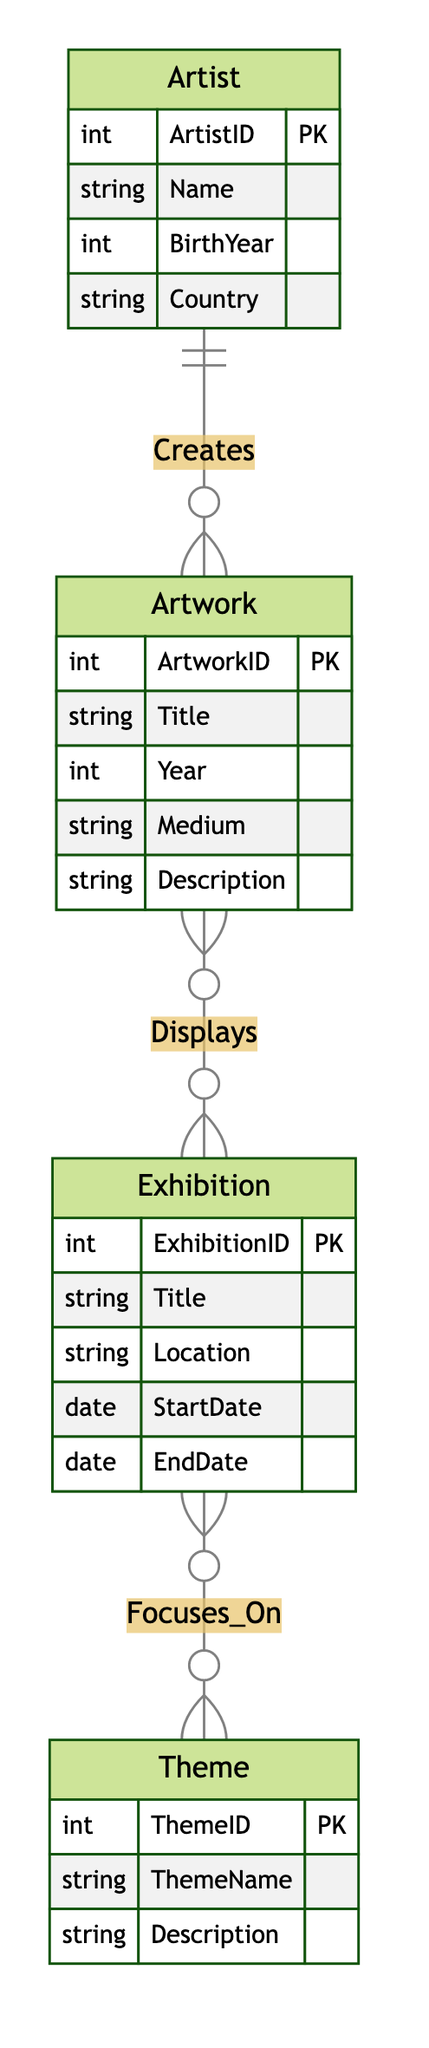What entities are present in the diagram? The diagram includes four entities: Artist, Artwork, Exhibition, and Theme. These are explicitly defined in the diagram structure, where each entity has a specific set of attributes.
Answer: Artist, Artwork, Exhibition, Theme How many attributes does the Artwork entity have? The Artwork entity has five attributes: ArtworkID, Title, Year, Medium, and Description. This can be counted directly from the attributes listed under the Artwork entity in the diagram.
Answer: 5 What is the cardinality of the relationship between Artist and Artwork? The relationship "Creates" connects Artist to Artwork, indicating that one Artist can create many Artworks (1 to M). This is derived from the cardinality notation next to the relationship line in the diagram.
Answer: 1 to M Which theme is associated with the Exhibition? The diagram indicates a many-to-many relationship between Exhibition and Theme through "Focuses_On", meaning an Exhibition can focus on multiple Themes, and a Theme can be associated with multiple Exhibitions. Therefore, several themes can be identified with an Exhibition.
Answer: Multiple Themes How are Artworks and Exhibitions related? The relationship "Displays" defines a many-to-many connection between Artwork and Exhibition, meaning each Artwork can be displayed in multiple Exhibitions, and each Exhibition can display many Artworks. This is represented by the cardinality notation near the relationship line.
Answer: Many-to-Many What is the primary key of the Artist entity? The Artist entity has ArtistID as its primary key. This is explicitly stated as part of the Artist entity definition in the diagram.
Answer: ArtistID How many entities are involved in the relationship "Displays"? The relationship "Displays" involves two entities: Artwork and Exhibition. This is directly identifiable as both entities are linked through the relationship in the diagram.
Answer: 2 What does the "Focuses_On" relationship imply about Exhibitions and Themes? The "Focuses_On" relationship implies that Exhibitions can focus on multiple Themes and vice versa, meaning the relationship is many-to-many. This is indicated by the cardinality notation adjacent to the relationship definition.
Answer: Many-to-Many 